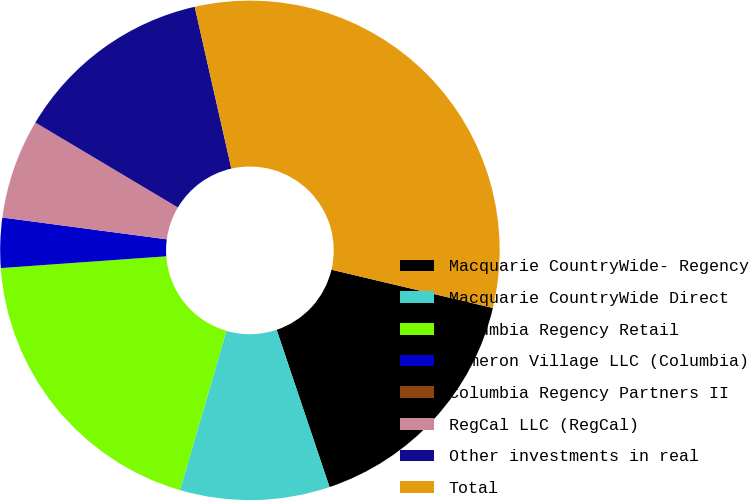<chart> <loc_0><loc_0><loc_500><loc_500><pie_chart><fcel>Macquarie CountryWide- Regency<fcel>Macquarie CountryWide Direct<fcel>Columbia Regency Retail<fcel>Cameron Village LLC (Columbia)<fcel>Columbia Regency Partners II<fcel>RegCal LLC (RegCal)<fcel>Other investments in real<fcel>Total<nl><fcel>16.13%<fcel>9.68%<fcel>19.35%<fcel>3.23%<fcel>0.0%<fcel>6.45%<fcel>12.9%<fcel>32.25%<nl></chart> 